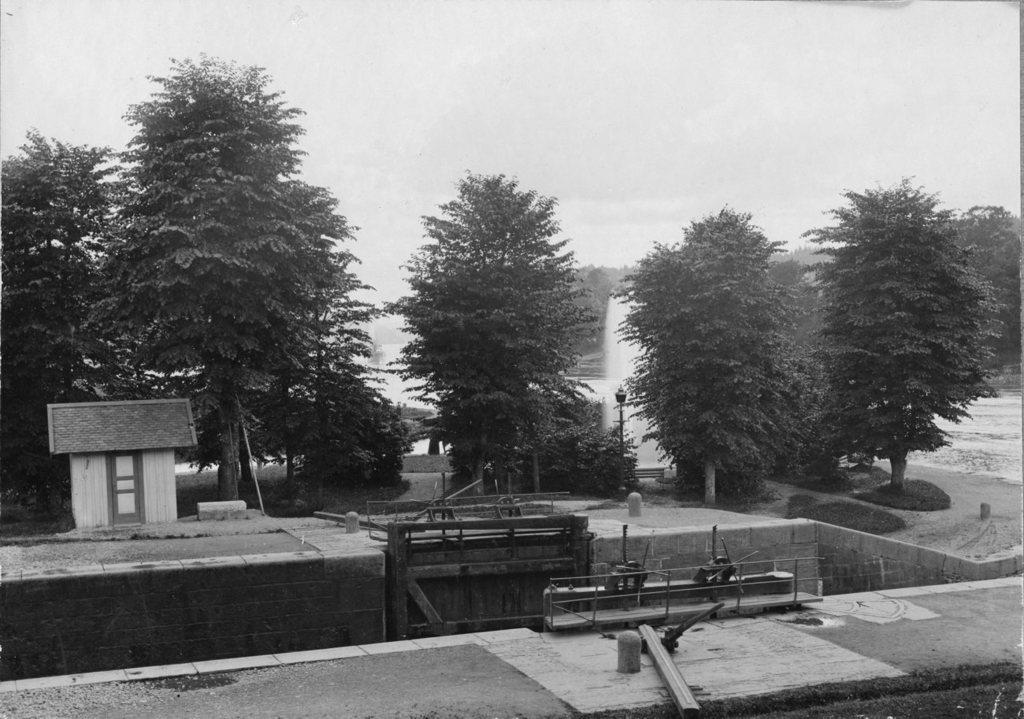How many roads can be seen in the image? There are two roads in the image. What type of vegetation is visible in the image? There are trees visible in the image. What structure can be seen in the image? There is a pole in the image. What feature is present for people to drink water? There is a water fountain in the image. What is the color scheme of the image? The image is in black and white. What part of the natural environment is visible in the image? The sky is visible in the image. What type of skin condition can be seen on the trees in the image? There is no mention of any skin condition on the trees in the image. What type of bean is growing on the pole in the image? There is no bean present in the image; it features a pole and other elements mentioned in the facts. 